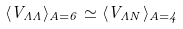<formula> <loc_0><loc_0><loc_500><loc_500>\langle V _ { \Lambda \Lambda } \rangle _ { A = 6 } \simeq \langle V _ { \Lambda N } \rangle _ { A = 4 }</formula> 